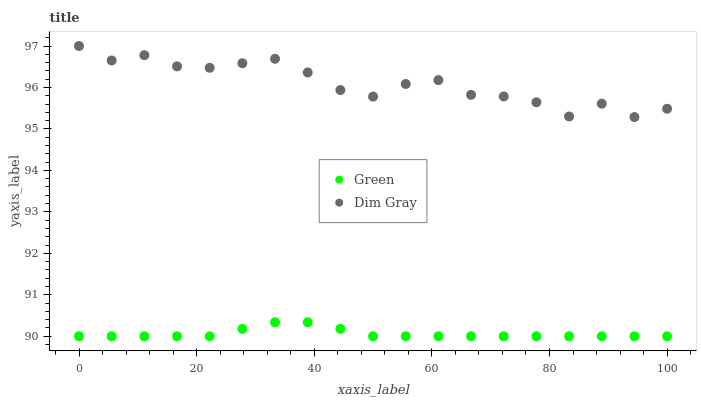Does Green have the minimum area under the curve?
Answer yes or no. Yes. Does Dim Gray have the maximum area under the curve?
Answer yes or no. Yes. Does Green have the maximum area under the curve?
Answer yes or no. No. Is Green the smoothest?
Answer yes or no. Yes. Is Dim Gray the roughest?
Answer yes or no. Yes. Is Green the roughest?
Answer yes or no. No. Does Green have the lowest value?
Answer yes or no. Yes. Does Dim Gray have the highest value?
Answer yes or no. Yes. Does Green have the highest value?
Answer yes or no. No. Is Green less than Dim Gray?
Answer yes or no. Yes. Is Dim Gray greater than Green?
Answer yes or no. Yes. Does Green intersect Dim Gray?
Answer yes or no. No. 